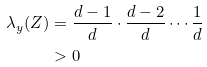Convert formula to latex. <formula><loc_0><loc_0><loc_500><loc_500>\lambda _ { y } ( Z ) & = \frac { d - 1 } { d } \cdot \frac { d - 2 } { d } \cdots \frac { 1 } { d } \\ & > 0</formula> 